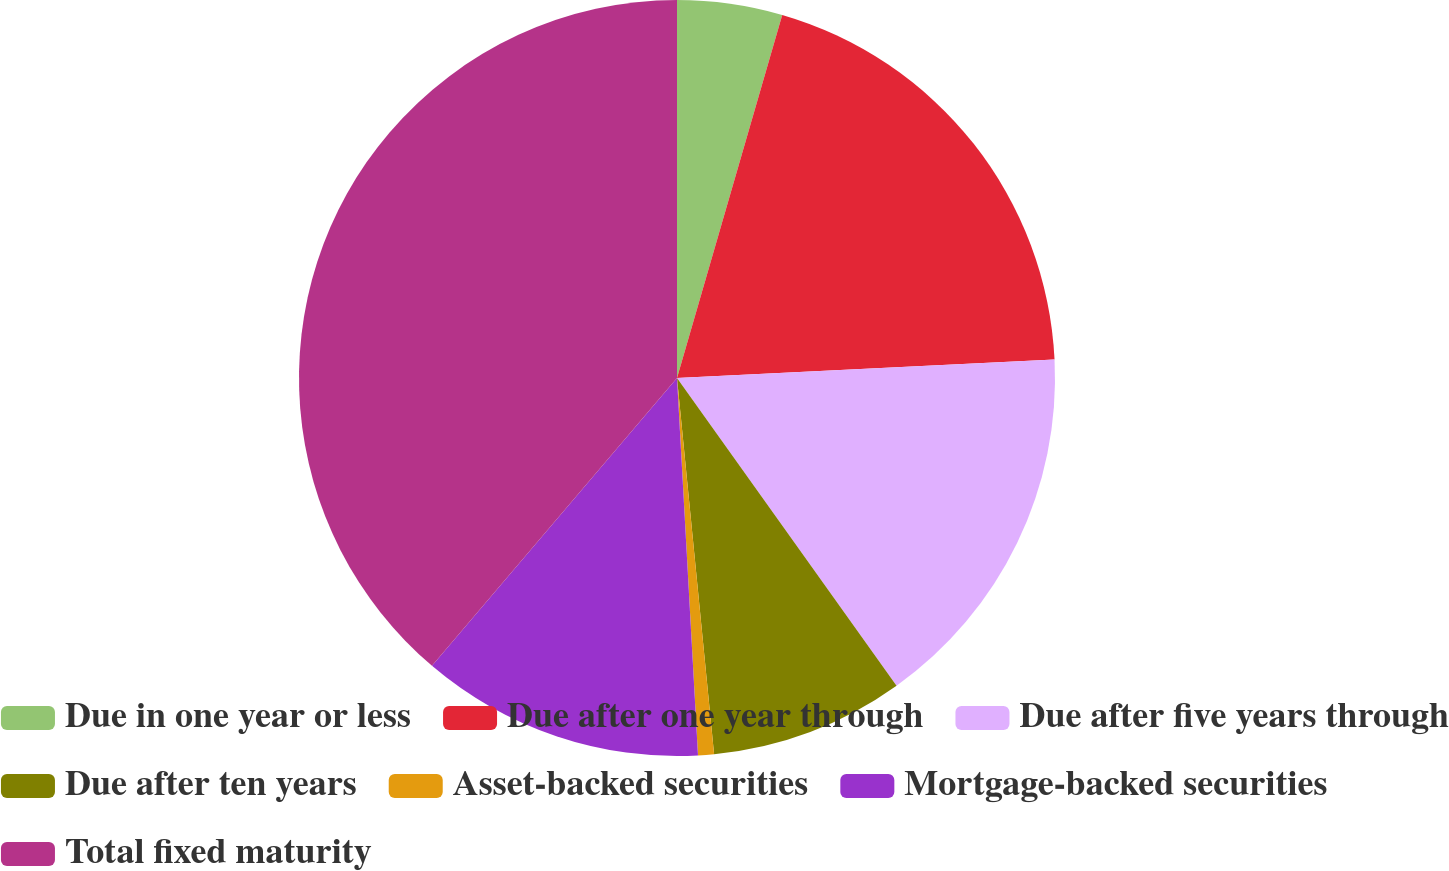<chart> <loc_0><loc_0><loc_500><loc_500><pie_chart><fcel>Due in one year or less<fcel>Due after one year through<fcel>Due after five years through<fcel>Due after ten years<fcel>Asset-backed securities<fcel>Mortgage-backed securities<fcel>Total fixed maturity<nl><fcel>4.49%<fcel>19.73%<fcel>15.92%<fcel>8.3%<fcel>0.68%<fcel>12.11%<fcel>38.78%<nl></chart> 